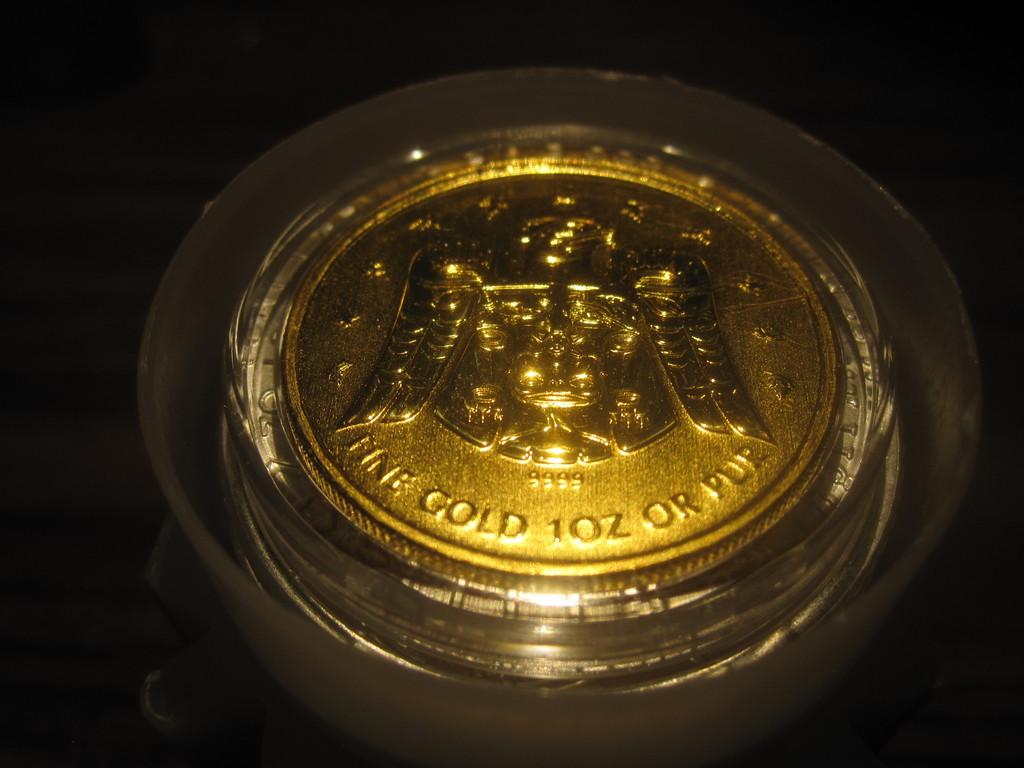<image>
Provide a brief description of the given image. The gold coin is just about 1 oz in size 